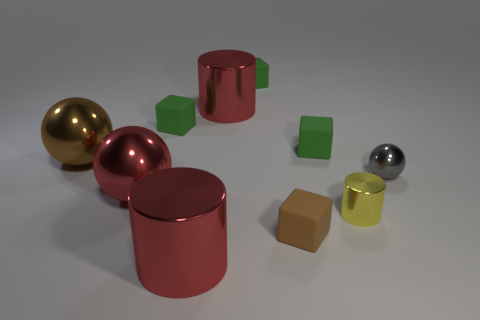Subtract all green cubes. How many were subtracted if there are1green cubes left? 2 Subtract all tiny gray balls. How many balls are left? 2 Subtract all brown blocks. How many blocks are left? 3 Subtract 3 cylinders. How many cylinders are left? 0 Subtract all cylinders. How many objects are left? 7 Subtract all blue spheres. How many purple blocks are left? 0 Add 1 big red metal cylinders. How many big red metal cylinders are left? 3 Add 7 small brown matte objects. How many small brown matte objects exist? 8 Subtract 0 green balls. How many objects are left? 10 Subtract all gray cylinders. Subtract all gray blocks. How many cylinders are left? 3 